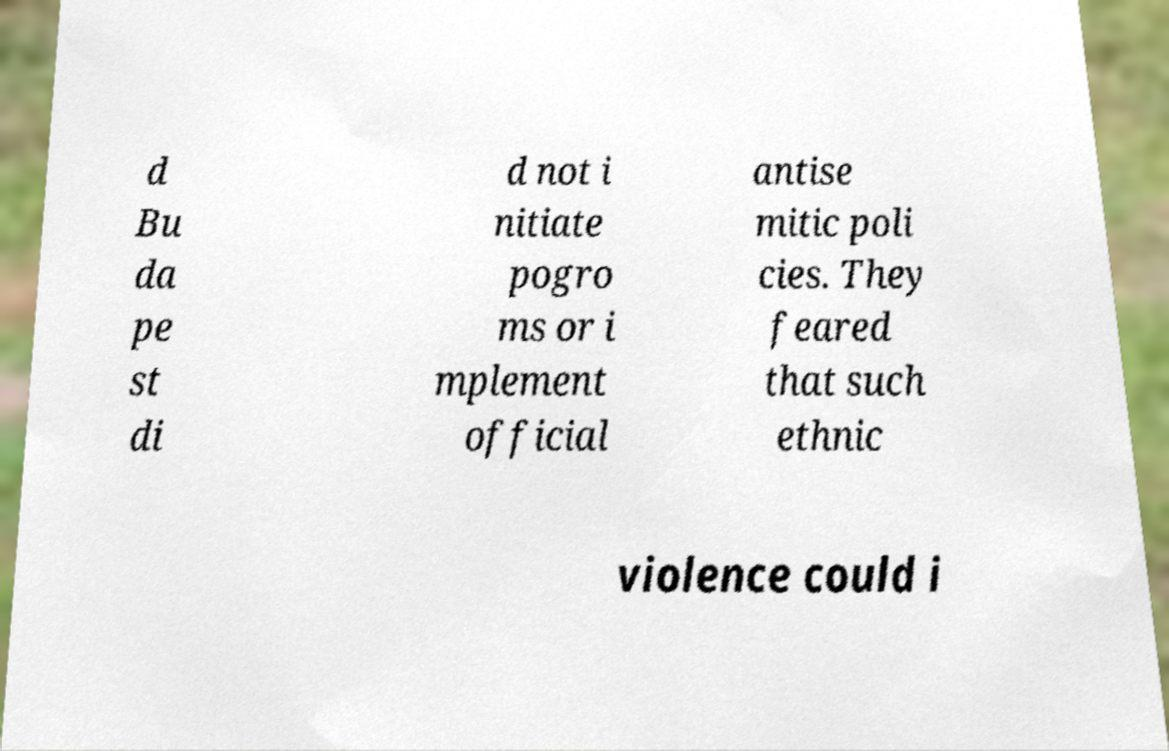Could you extract and type out the text from this image? d Bu da pe st di d not i nitiate pogro ms or i mplement official antise mitic poli cies. They feared that such ethnic violence could i 